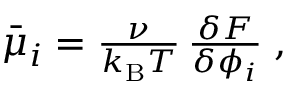<formula> <loc_0><loc_0><loc_500><loc_500>\begin{array} { r } { \bar { \mu } _ { i } = \frac { \nu } { k _ { B } T } \, \frac { \delta F } { \delta \phi _ { i } } \, , } \end{array}</formula> 